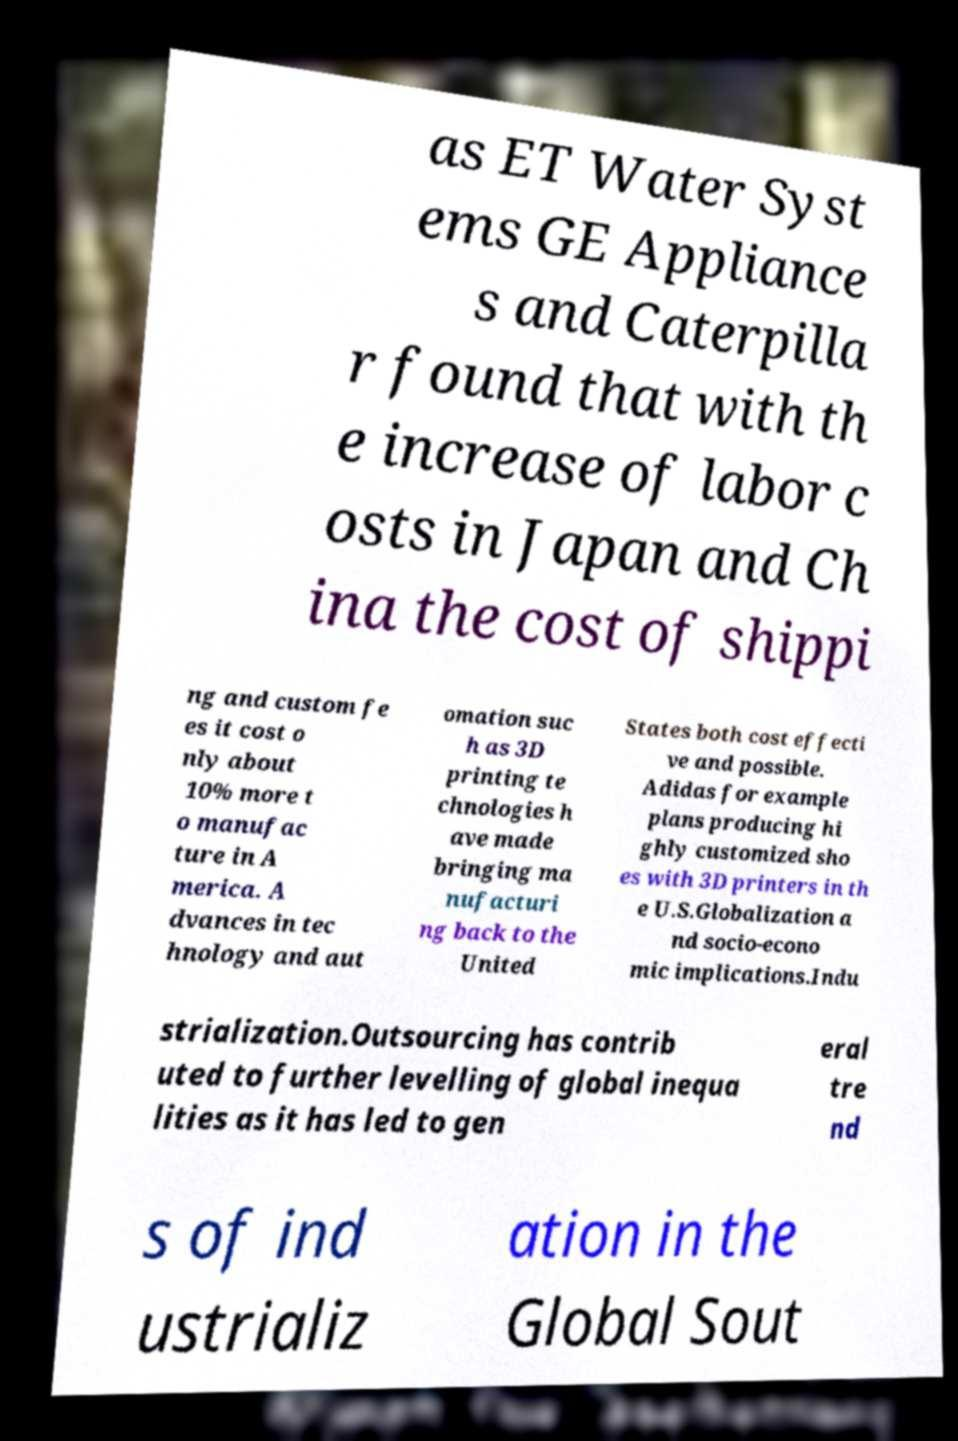For documentation purposes, I need the text within this image transcribed. Could you provide that? as ET Water Syst ems GE Appliance s and Caterpilla r found that with th e increase of labor c osts in Japan and Ch ina the cost of shippi ng and custom fe es it cost o nly about 10% more t o manufac ture in A merica. A dvances in tec hnology and aut omation suc h as 3D printing te chnologies h ave made bringing ma nufacturi ng back to the United States both cost effecti ve and possible. Adidas for example plans producing hi ghly customized sho es with 3D printers in th e U.S.Globalization a nd socio-econo mic implications.Indu strialization.Outsourcing has contrib uted to further levelling of global inequa lities as it has led to gen eral tre nd s of ind ustrializ ation in the Global Sout 